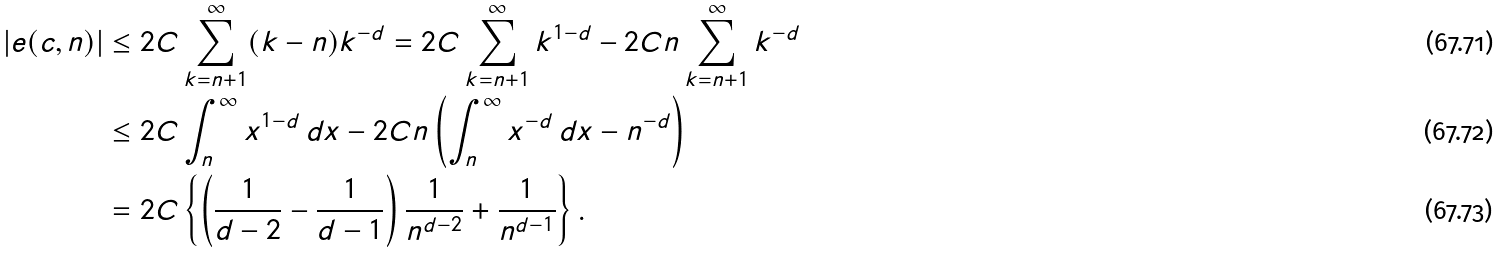<formula> <loc_0><loc_0><loc_500><loc_500>| e ( c , n ) | & \leq 2 C \sum _ { k = n + 1 } ^ { \infty } ( k - n ) k ^ { - d } = 2 C \sum _ { k = n + 1 } ^ { \infty } k ^ { 1 - d } - 2 C n \sum _ { k = n + 1 } ^ { \infty } k ^ { - d } \\ & \leq 2 C \int _ { n } ^ { \infty } x ^ { 1 - d } \, d x - 2 C n \left ( \int _ { n } ^ { \infty } x ^ { - d } \, d x - n ^ { - d } \right ) \\ & = 2 C \left \{ \left ( \frac { 1 } { d - 2 } - \frac { 1 } { d - 1 } \right ) \frac { 1 } { n ^ { d - 2 } } + \frac { 1 } { n ^ { d - 1 } } \right \} .</formula> 